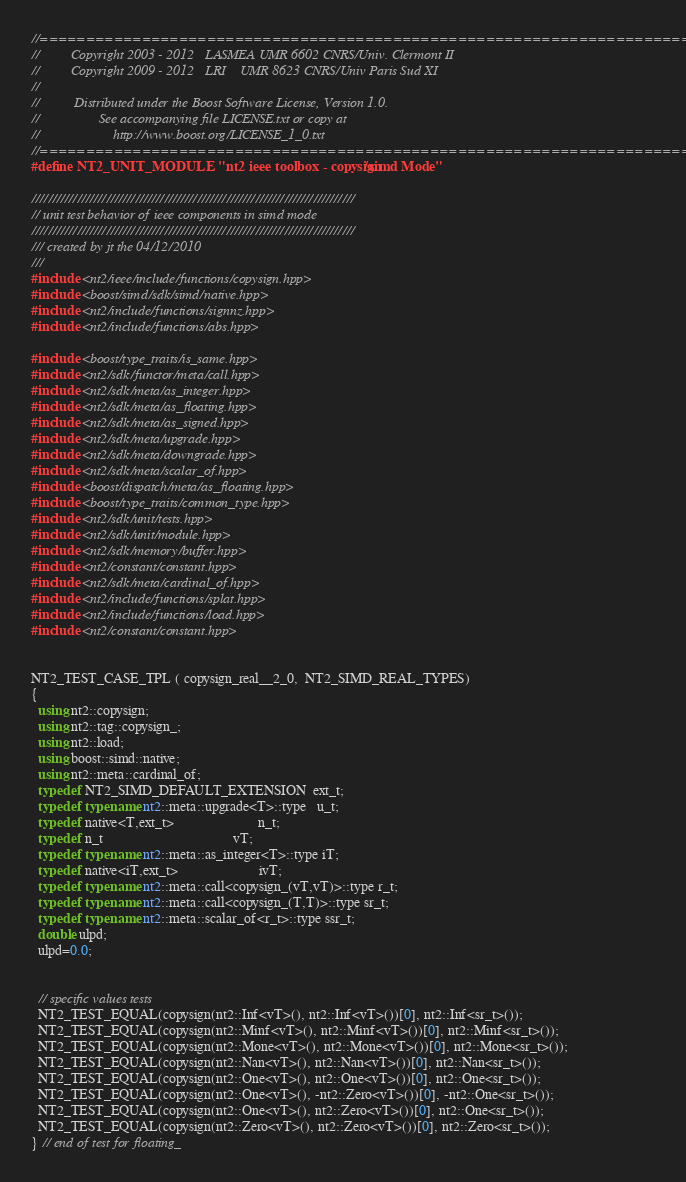<code> <loc_0><loc_0><loc_500><loc_500><_C++_>//==============================================================================
//         Copyright 2003 - 2012   LASMEA UMR 6602 CNRS/Univ. Clermont II
//         Copyright 2009 - 2012   LRI    UMR 8623 CNRS/Univ Paris Sud XI
//
//          Distributed under the Boost Software License, Version 1.0.
//                 See accompanying file LICENSE.txt or copy at
//                     http://www.boost.org/LICENSE_1_0.txt
//==============================================================================
#define NT2_UNIT_MODULE "nt2 ieee toolbox - copysign/simd Mode"

//////////////////////////////////////////////////////////////////////////////
// unit test behavior of ieee components in simd mode
//////////////////////////////////////////////////////////////////////////////
/// created by jt the 04/12/2010
///
#include <nt2/ieee/include/functions/copysign.hpp>
#include <boost/simd/sdk/simd/native.hpp>
#include <nt2/include/functions/signnz.hpp>
#include <nt2/include/functions/abs.hpp>

#include <boost/type_traits/is_same.hpp>
#include <nt2/sdk/functor/meta/call.hpp>
#include <nt2/sdk/meta/as_integer.hpp>
#include <nt2/sdk/meta/as_floating.hpp>
#include <nt2/sdk/meta/as_signed.hpp>
#include <nt2/sdk/meta/upgrade.hpp>
#include <nt2/sdk/meta/downgrade.hpp>
#include <nt2/sdk/meta/scalar_of.hpp>
#include <boost/dispatch/meta/as_floating.hpp>
#include <boost/type_traits/common_type.hpp>
#include <nt2/sdk/unit/tests.hpp>
#include <nt2/sdk/unit/module.hpp>
#include <nt2/sdk/memory/buffer.hpp>
#include <nt2/constant/constant.hpp>
#include <nt2/sdk/meta/cardinal_of.hpp>
#include <nt2/include/functions/splat.hpp>
#include <nt2/include/functions/load.hpp>
#include <nt2/constant/constant.hpp>


NT2_TEST_CASE_TPL ( copysign_real__2_0,  NT2_SIMD_REAL_TYPES)
{
  using nt2::copysign;
  using nt2::tag::copysign_;
  using nt2::load;
  using boost::simd::native;
  using nt2::meta::cardinal_of;
  typedef NT2_SIMD_DEFAULT_EXTENSION  ext_t;
  typedef typename nt2::meta::upgrade<T>::type   u_t;
  typedef native<T,ext_t>                        n_t;
  typedef n_t                                     vT;
  typedef typename nt2::meta::as_integer<T>::type iT;
  typedef native<iT,ext_t>                       ivT;
  typedef typename nt2::meta::call<copysign_(vT,vT)>::type r_t;
  typedef typename nt2::meta::call<copysign_(T,T)>::type sr_t;
  typedef typename nt2::meta::scalar_of<r_t>::type ssr_t;
  double ulpd;
  ulpd=0.0;


  // specific values tests
  NT2_TEST_EQUAL(copysign(nt2::Inf<vT>(), nt2::Inf<vT>())[0], nt2::Inf<sr_t>());
  NT2_TEST_EQUAL(copysign(nt2::Minf<vT>(), nt2::Minf<vT>())[0], nt2::Minf<sr_t>());
  NT2_TEST_EQUAL(copysign(nt2::Mone<vT>(), nt2::Mone<vT>())[0], nt2::Mone<sr_t>());
  NT2_TEST_EQUAL(copysign(nt2::Nan<vT>(), nt2::Nan<vT>())[0], nt2::Nan<sr_t>());
  NT2_TEST_EQUAL(copysign(nt2::One<vT>(), nt2::One<vT>())[0], nt2::One<sr_t>());
  NT2_TEST_EQUAL(copysign(nt2::One<vT>(), -nt2::Zero<vT>())[0], -nt2::One<sr_t>());
  NT2_TEST_EQUAL(copysign(nt2::One<vT>(), nt2::Zero<vT>())[0], nt2::One<sr_t>());
  NT2_TEST_EQUAL(copysign(nt2::Zero<vT>(), nt2::Zero<vT>())[0], nt2::Zero<sr_t>());
} // end of test for floating_
</code> 